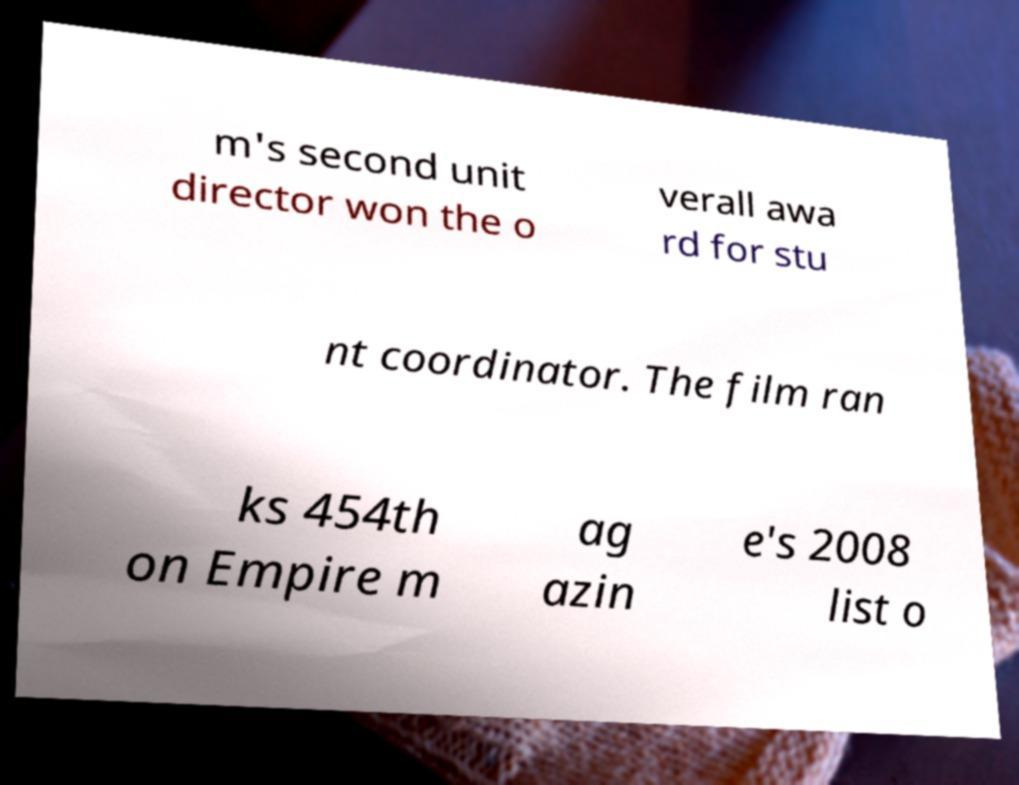Please read and relay the text visible in this image. What does it say? m's second unit director won the o verall awa rd for stu nt coordinator. The film ran ks 454th on Empire m ag azin e's 2008 list o 